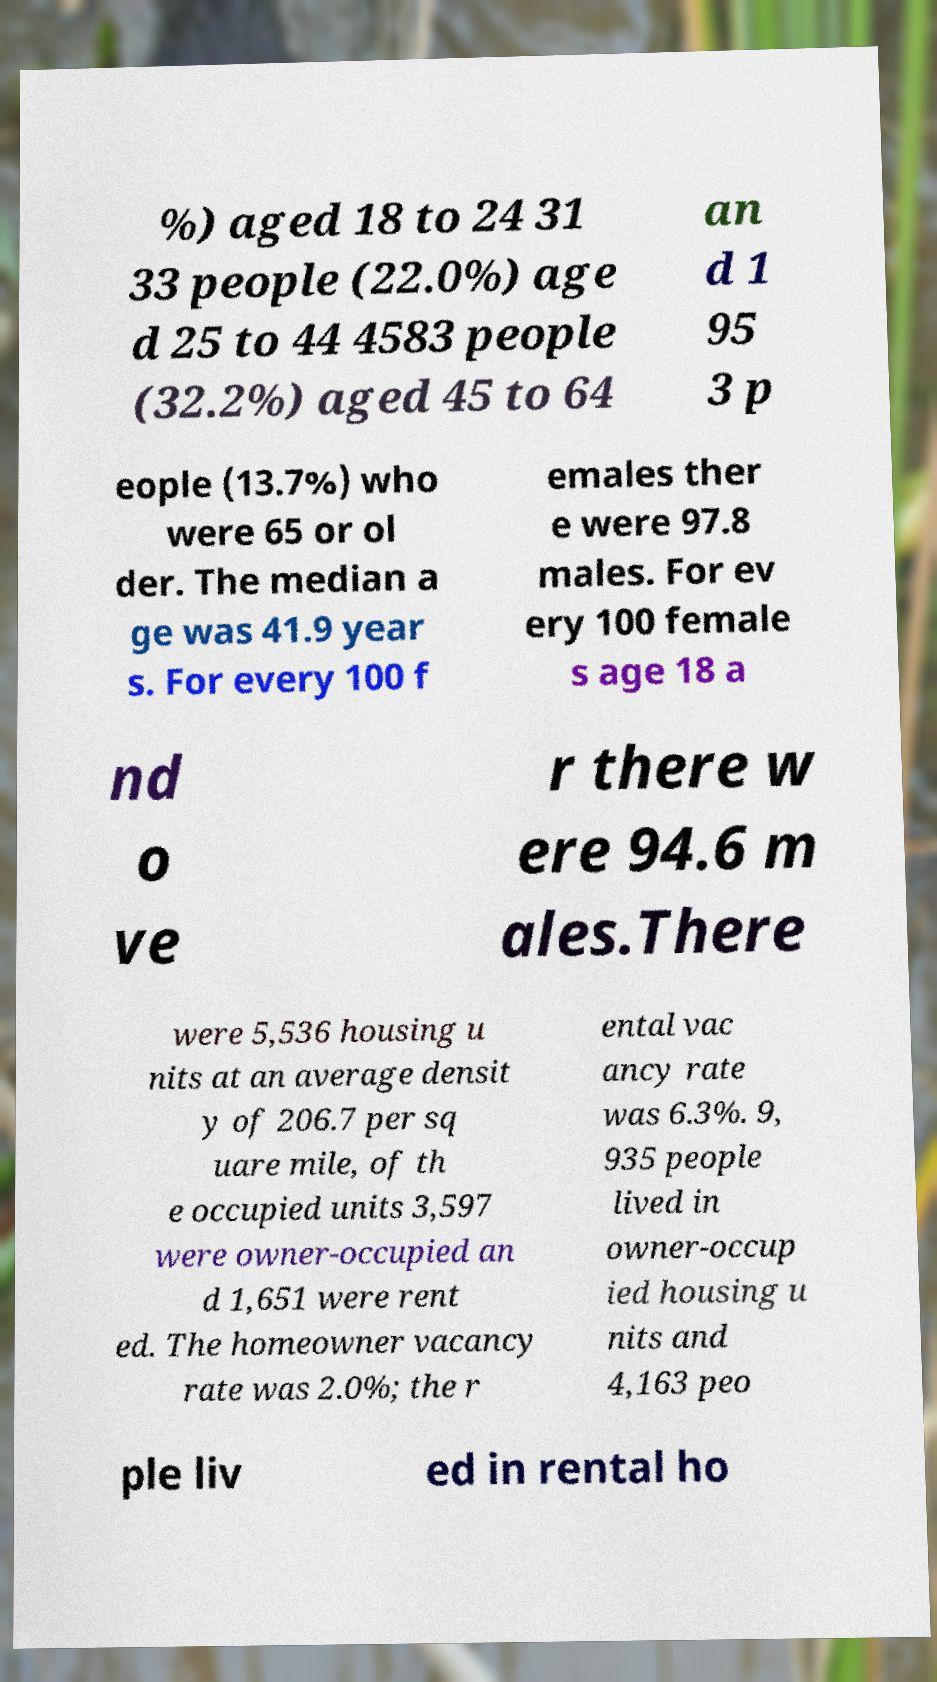Please identify and transcribe the text found in this image. %) aged 18 to 24 31 33 people (22.0%) age d 25 to 44 4583 people (32.2%) aged 45 to 64 an d 1 95 3 p eople (13.7%) who were 65 or ol der. The median a ge was 41.9 year s. For every 100 f emales ther e were 97.8 males. For ev ery 100 female s age 18 a nd o ve r there w ere 94.6 m ales.There were 5,536 housing u nits at an average densit y of 206.7 per sq uare mile, of th e occupied units 3,597 were owner-occupied an d 1,651 were rent ed. The homeowner vacancy rate was 2.0%; the r ental vac ancy rate was 6.3%. 9, 935 people lived in owner-occup ied housing u nits and 4,163 peo ple liv ed in rental ho 